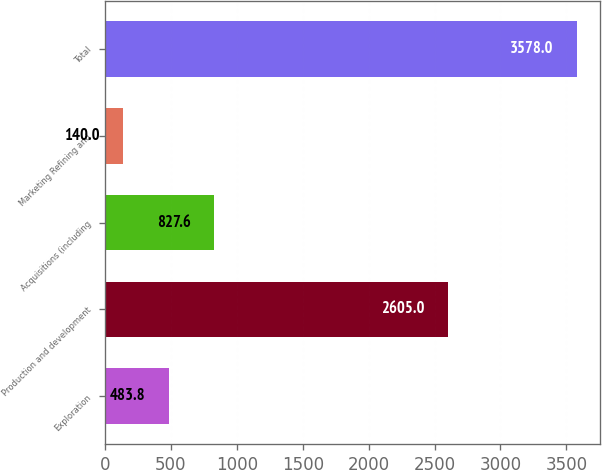<chart> <loc_0><loc_0><loc_500><loc_500><bar_chart><fcel>Exploration<fcel>Production and development<fcel>Acquisitions (including<fcel>Marketing Refining and<fcel>Total<nl><fcel>483.8<fcel>2605<fcel>827.6<fcel>140<fcel>3578<nl></chart> 